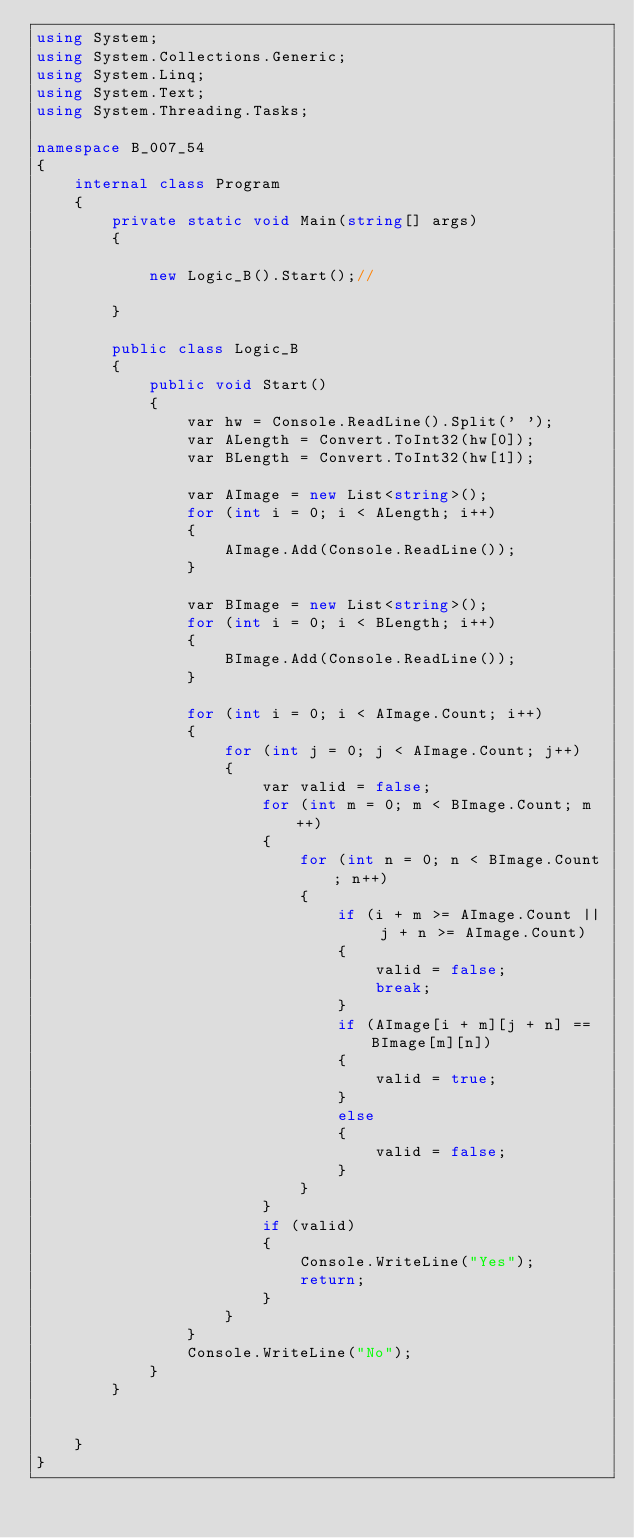<code> <loc_0><loc_0><loc_500><loc_500><_C#_>using System;
using System.Collections.Generic;
using System.Linq;
using System.Text;
using System.Threading.Tasks;

namespace B_007_54
{
    internal class Program
    {
        private static void Main(string[] args)
        {

            new Logic_B().Start();//

        }

        public class Logic_B
        {
            public void Start()
            {
                var hw = Console.ReadLine().Split(' ');
                var ALength = Convert.ToInt32(hw[0]);
                var BLength = Convert.ToInt32(hw[1]);

                var AImage = new List<string>();
                for (int i = 0; i < ALength; i++)
                {
                    AImage.Add(Console.ReadLine());
                }

                var BImage = new List<string>();
                for (int i = 0; i < BLength; i++)
                {
                    BImage.Add(Console.ReadLine());
                }

                for (int i = 0; i < AImage.Count; i++)
                {
                    for (int j = 0; j < AImage.Count; j++)
                    {
                        var valid = false;
                        for (int m = 0; m < BImage.Count; m++)
                        {
                            for (int n = 0; n < BImage.Count; n++)
                            {
                                if (i + m >= AImage.Count || j + n >= AImage.Count)
                                {
                                    valid = false;
                                    break;
                                }
                                if (AImage[i + m][j + n] == BImage[m][n])
                                {
                                    valid = true;
                                }
                                else
                                {
                                    valid = false;
                                }
                            }
                        }
                        if (valid)
                        {
                            Console.WriteLine("Yes");
                            return;
                        }
                    }
                }
                Console.WriteLine("No");
            }
        }

        
    }
}</code> 